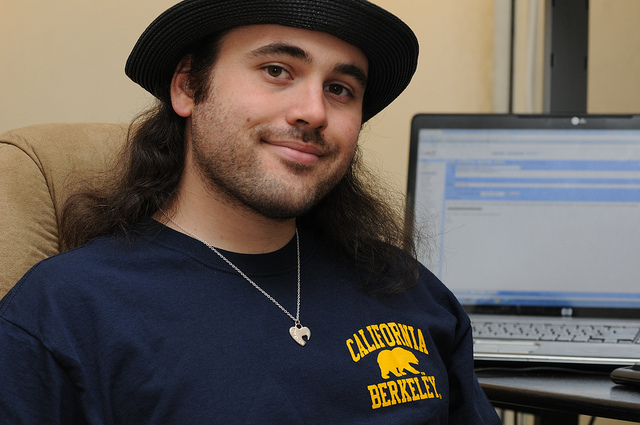<image>What uniforms are shown? I am not sure what uniforms are shown. It could be either Berkeley or California Berkeley or there could be no uniform at all. What uniforms are shown? I don't know what uniforms are shown in the image. It could be 'berkeley', 'california berkeley', 'university' or 'school'. 